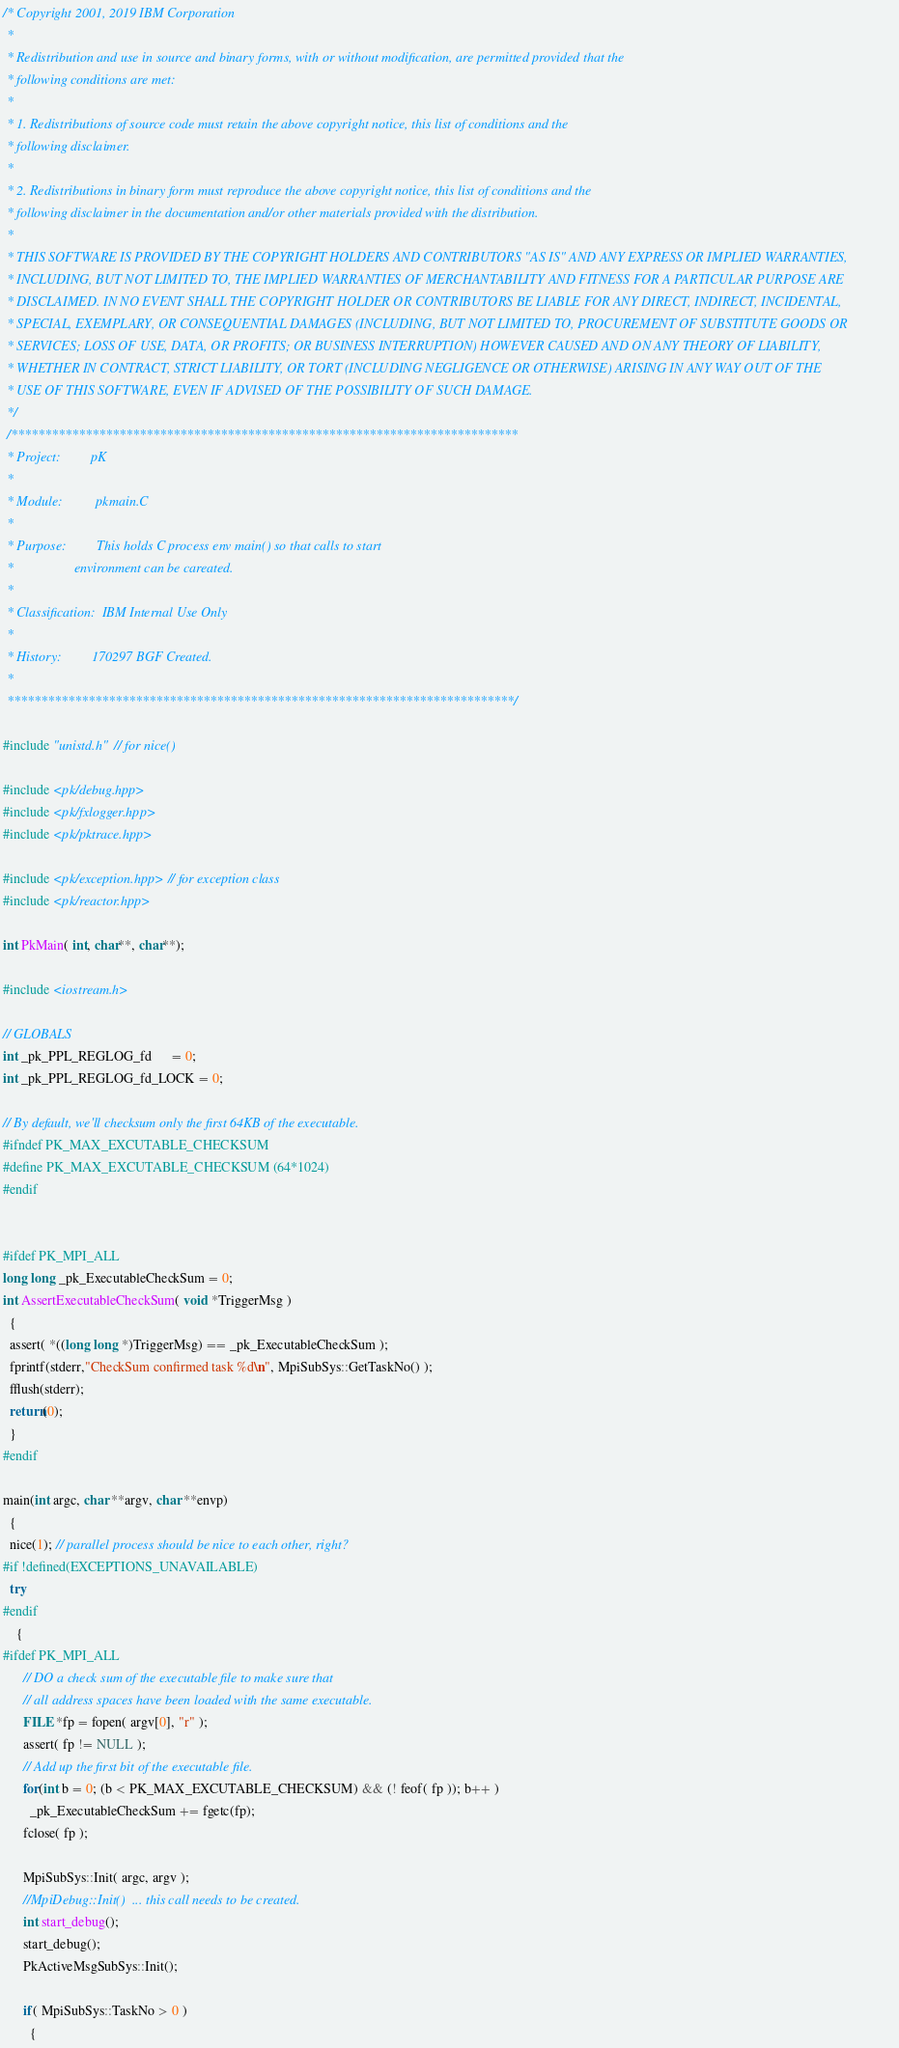Convert code to text. <code><loc_0><loc_0><loc_500><loc_500><_C++_>/* Copyright 2001, 2019 IBM Corporation
 *
 * Redistribution and use in source and binary forms, with or without modification, are permitted provided that the 
 * following conditions are met:
 *
 * 1. Redistributions of source code must retain the above copyright notice, this list of conditions and the 
 * following disclaimer.
 *
 * 2. Redistributions in binary form must reproduce the above copyright notice, this list of conditions and the 
 * following disclaimer in the documentation and/or other materials provided with the distribution.
 *
 * THIS SOFTWARE IS PROVIDED BY THE COPYRIGHT HOLDERS AND CONTRIBUTORS "AS IS" AND ANY EXPRESS OR IMPLIED WARRANTIES, 
 * INCLUDING, BUT NOT LIMITED TO, THE IMPLIED WARRANTIES OF MERCHANTABILITY AND FITNESS FOR A PARTICULAR PURPOSE ARE 
 * DISCLAIMED. IN NO EVENT SHALL THE COPYRIGHT HOLDER OR CONTRIBUTORS BE LIABLE FOR ANY DIRECT, INDIRECT, INCIDENTAL, 
 * SPECIAL, EXEMPLARY, OR CONSEQUENTIAL DAMAGES (INCLUDING, BUT NOT LIMITED TO, PROCUREMENT OF SUBSTITUTE GOODS OR 
 * SERVICES; LOSS OF USE, DATA, OR PROFITS; OR BUSINESS INTERRUPTION) HOWEVER CAUSED AND ON ANY THEORY OF LIABILITY, 
 * WHETHER IN CONTRACT, STRICT LIABILITY, OR TORT (INCLUDING NEGLIGENCE OR OTHERWISE) ARISING IN ANY WAY OUT OF THE 
 * USE OF THIS SOFTWARE, EVEN IF ADVISED OF THE POSSIBILITY OF SUCH DAMAGE.
 */
 /***************************************************************************
 * Project:         pK
 *
 * Module:          pkmain.C
 *
 * Purpose:         This holds C process env main() so that calls to start
 *                  environment can be careated.
 *
 * Classification:  IBM Internal Use Only
 *
 * History:         170297 BGF Created.
 *
 ***************************************************************************/

#include "unistd.h"  // for nice()

#include <pk/debug.hpp>
#include <pk/fxlogger.hpp>
#include <pk/pktrace.hpp>

#include <pk/exception.hpp> // for exception class
#include <pk/reactor.hpp>

int PkMain( int, char**, char**);

#include <iostream.h>

// GLOBALS
int _pk_PPL_REGLOG_fd      = 0;
int _pk_PPL_REGLOG_fd_LOCK = 0;

// By default, we'll checksum only the first 64KB of the executable.
#ifndef PK_MAX_EXCUTABLE_CHECKSUM
#define PK_MAX_EXCUTABLE_CHECKSUM (64*1024)
#endif


#ifdef PK_MPI_ALL
long long _pk_ExecutableCheckSum = 0;
int AssertExecutableCheckSum( void *TriggerMsg )
  {
  assert( *((long long *)TriggerMsg) == _pk_ExecutableCheckSum );
  fprintf(stderr,"CheckSum confirmed task %d\n", MpiSubSys::GetTaskNo() );
  fflush(stderr);
  return(0);
  }
#endif

main(int argc, char **argv, char **envp)
  {
  nice(1); // parallel process should be nice to each other, right?
#if !defined(EXCEPTIONS_UNAVAILABLE)
  try
#endif
    {
#ifdef PK_MPI_ALL
      // DO a check sum of the executable file to make sure that
      // all address spaces have been loaded with the same executable.
      FILE *fp = fopen( argv[0], "r" );
      assert( fp != NULL );
      // Add up the first bit of the executable file.
      for(int b = 0; (b < PK_MAX_EXCUTABLE_CHECKSUM) && (! feof( fp )); b++ )
        _pk_ExecutableCheckSum += fgetc(fp);
      fclose( fp );

      MpiSubSys::Init( argc, argv );
      //MpiDebug::Init()  ... this call needs to be created.
      int start_debug();
      start_debug();
      PkActiveMsgSubSys::Init();

      if( MpiSubSys::TaskNo > 0 )
        {</code> 